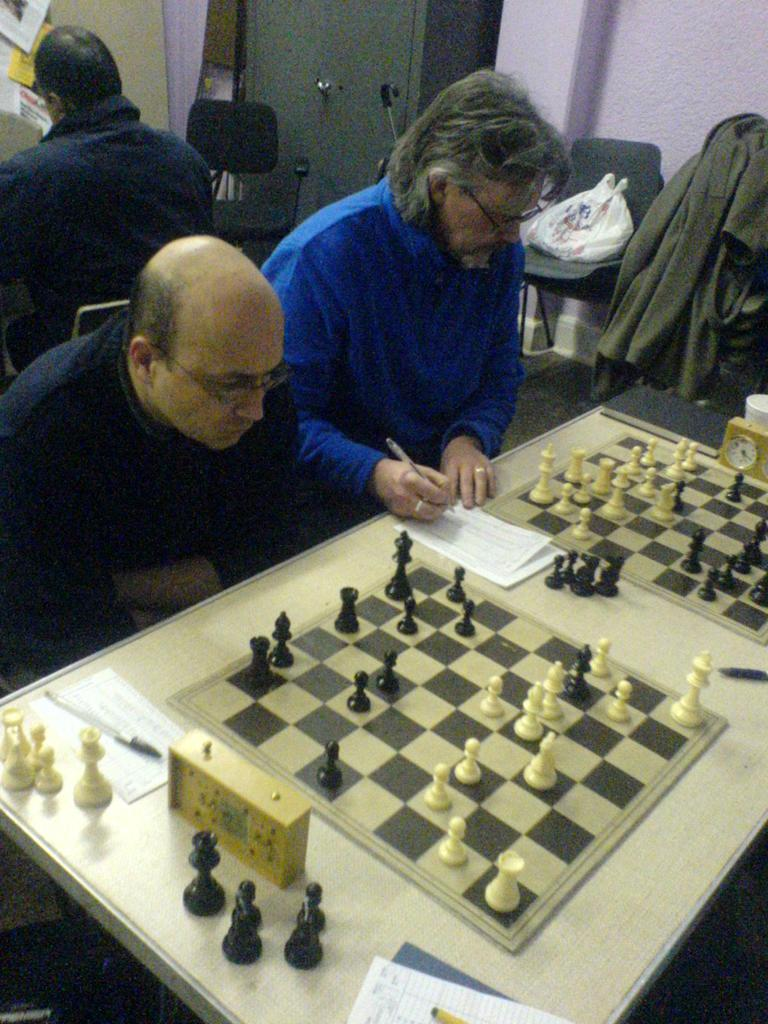How many men are in the image? There are three men in the image. What are the men doing in the image? The men are sitting on chairs. What is on the table in the image? There are chess boards, papers, and a pen on the table. What can be seen in the background of the image? There is a wall, a plastic cover, and a cupboard in the background of the image. What type of books can be seen on the table in the image? There are no books present on the table in the image. 